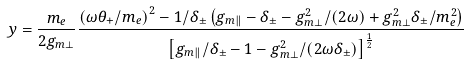Convert formula to latex. <formula><loc_0><loc_0><loc_500><loc_500>y = \frac { m _ { e } } { 2 g _ { m \perp } } \frac { \left ( \omega \theta _ { + } / m _ { e } \right ) ^ { 2 } - 1 / \delta _ { \pm } \left ( g _ { m \| } - \delta _ { \pm } - g _ { m \perp } ^ { 2 } / \left ( 2 \omega \right ) + g _ { m \perp } ^ { 2 } \delta _ { \pm } / m _ { e } ^ { 2 } \right ) } { \left [ g _ { m \| } / \delta _ { \pm } - 1 - g _ { m \perp } ^ { 2 } / \left ( 2 \omega \delta _ { \pm } \right ) \right ] ^ { \frac { 1 } { 2 } } }</formula> 